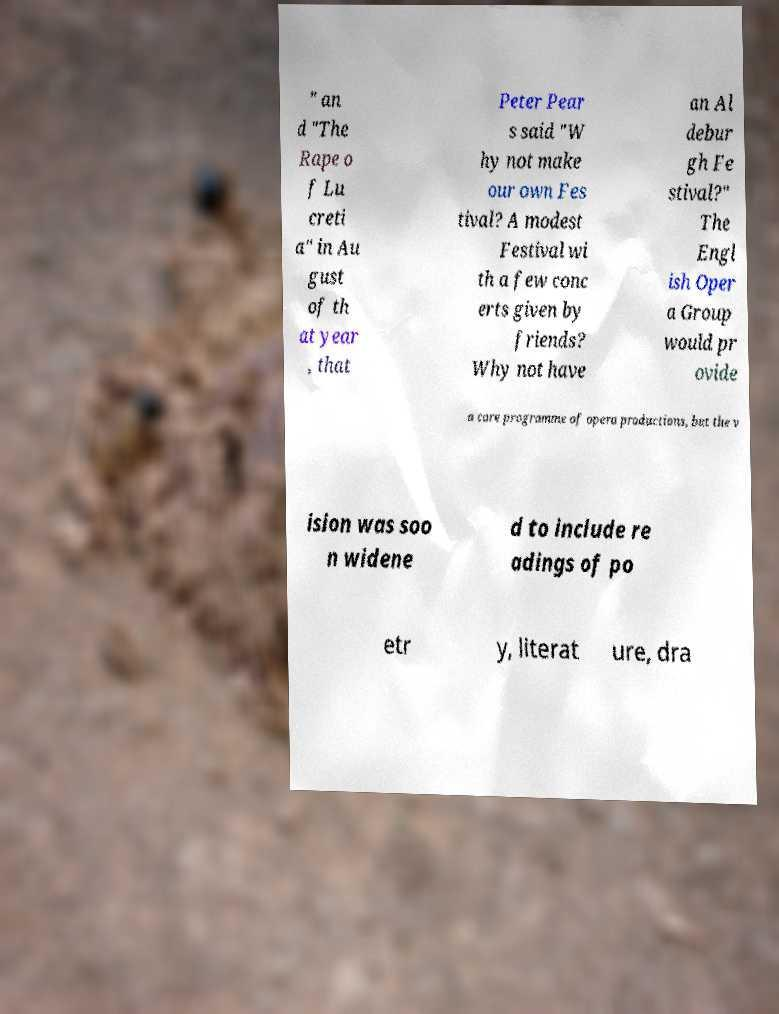Please read and relay the text visible in this image. What does it say? " an d "The Rape o f Lu creti a" in Au gust of th at year , that Peter Pear s said "W hy not make our own Fes tival? A modest Festival wi th a few conc erts given by friends? Why not have an Al debur gh Fe stival?" The Engl ish Oper a Group would pr ovide a core programme of opera productions, but the v ision was soo n widene d to include re adings of po etr y, literat ure, dra 